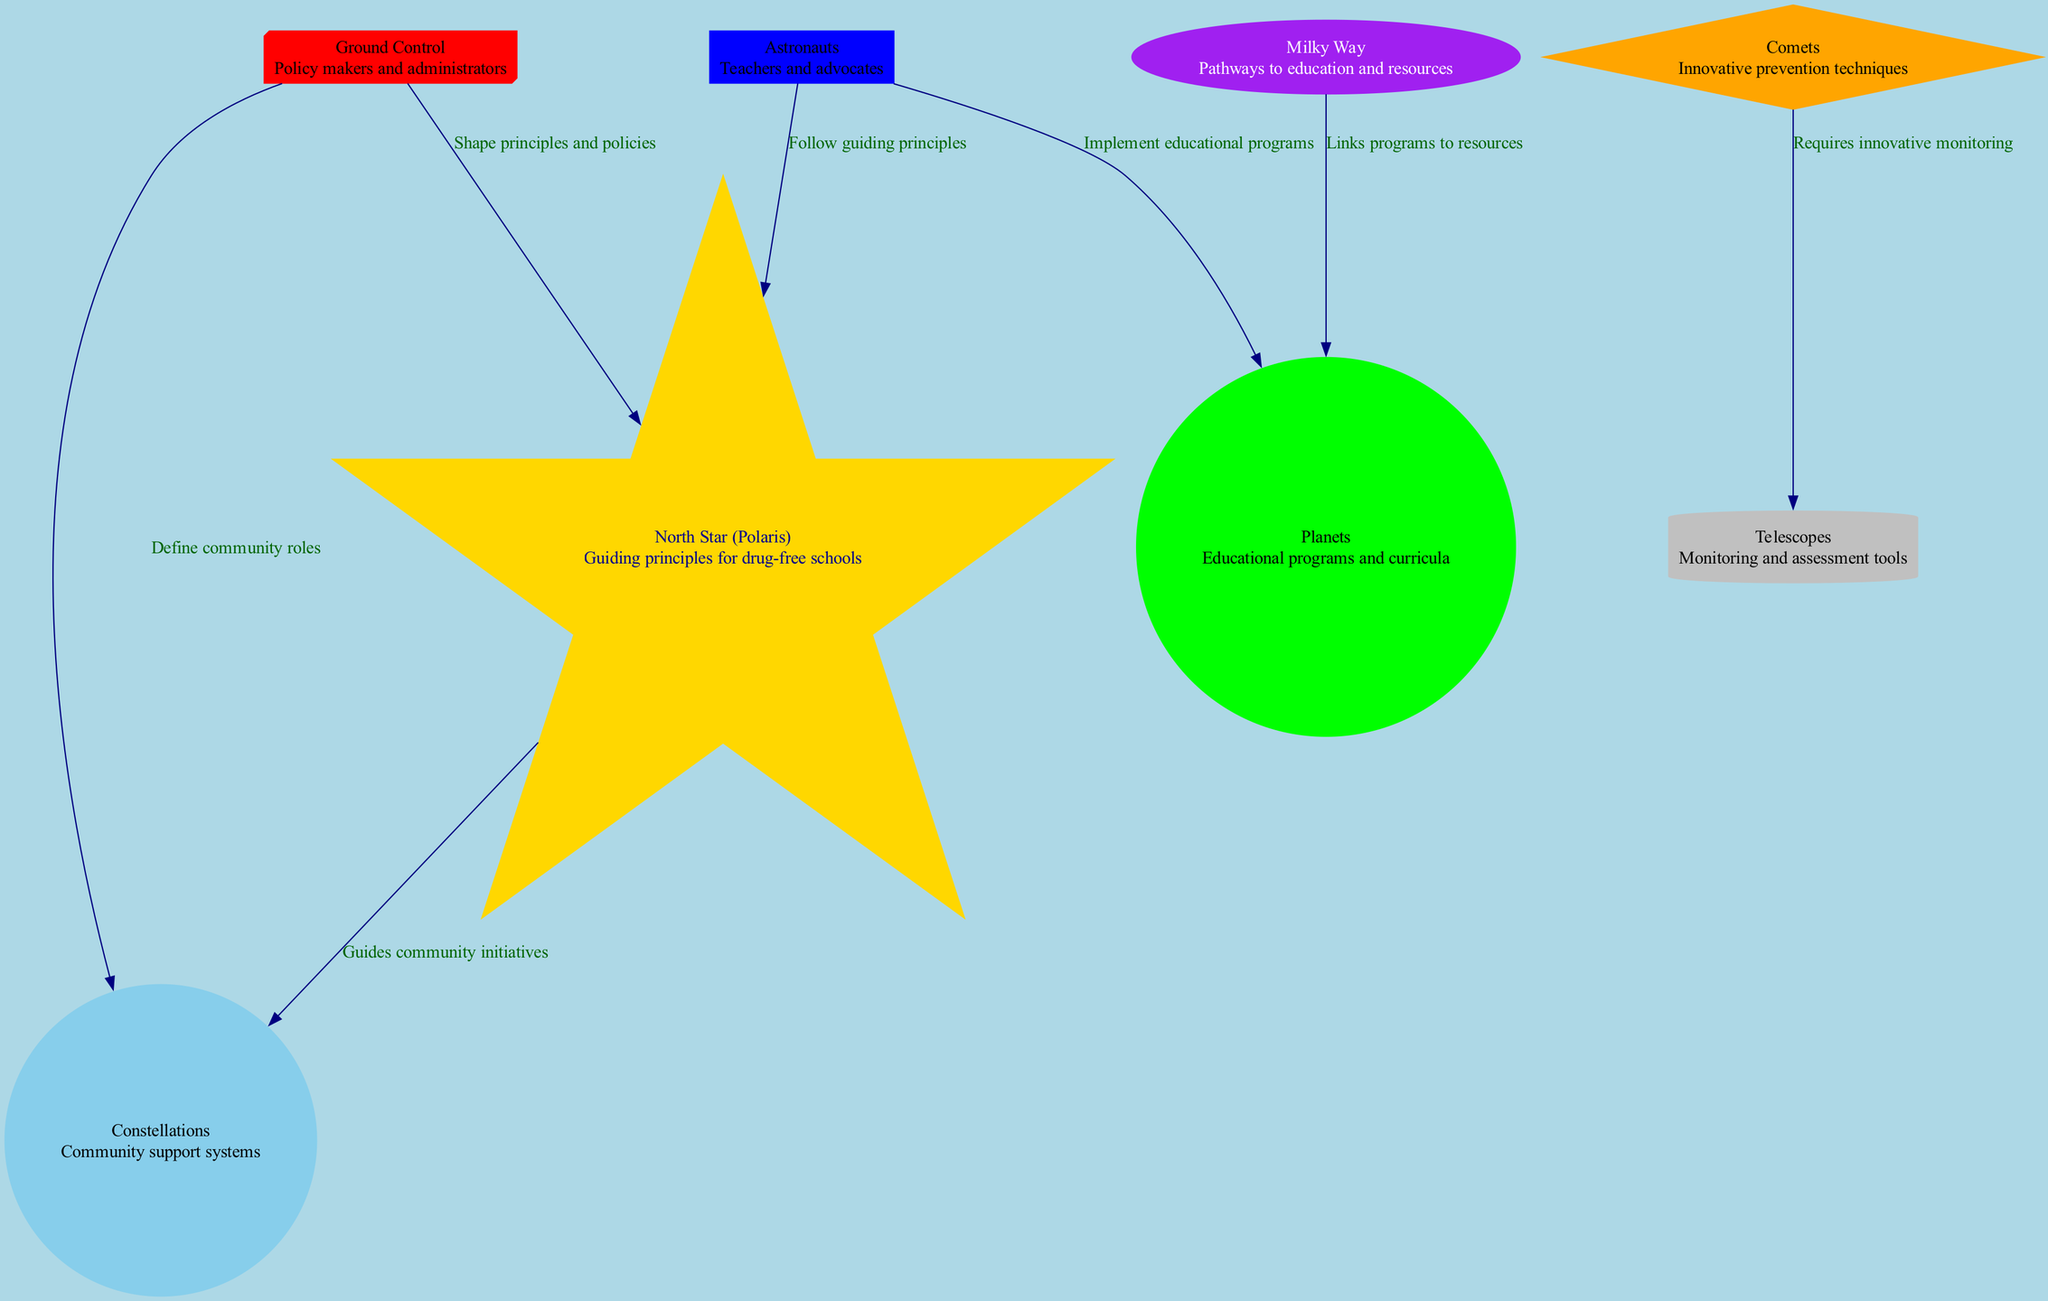What is the guiding principle in the diagram? The node labeled 'North Star (Polaris)' represents the guiding principles for drug-free schools, clearly stated within its description.
Answer: North Star (Polaris) How many nodes are present in the diagram? By counting the nodes listed in the data provided, there are 8 distinct nodes illustrated.
Answer: 8 What does the 'Milky Way' represent? The 'Milky Way' node's description indicates it symbolizes pathways to education and resources for drug-free initiatives.
Answer: Pathways to education and resources Which node follows the 'North Star' according to the diagram? The edge labeled 'Guides community initiatives' indicates that the 'North Star' connects to 'Constellations', showing that it directly follows it.
Answer: Constellations What do 'Astronauts' implement according to the diagram? The edge from 'Astronauts' to 'Planets' states that they implement educational programs as per the description given.
Answer: Educational programs Which node requires innovative monitoring? The edge connecting 'Comets' to 'Telescopes' specifies that 'Comets' require innovative monitoring according to the relationships depicted in the diagram.
Answer: Telescopes What role does 'Ground Control' play according to the diagram? The 'Ground Control' node has a connection to the 'North Star', indicating that it shapes principles and policies, thereby playing an important policy-making role.
Answer: Shape principles and policies How do the 'Constellations' relate to the 'Ground Control'? The directed edge from 'Ground Control' to 'Constellations' states that it directly defines community roles, showing the relationship between these two nodes.
Answer: Define community roles What is linked by the 'Milky Way'? The relationship shown between 'Milky Way' and 'Planets', as labeled 'Links programs to resources', specifies that the 'Milky Way' links educational programs to resources.
Answer: Links programs to resources 